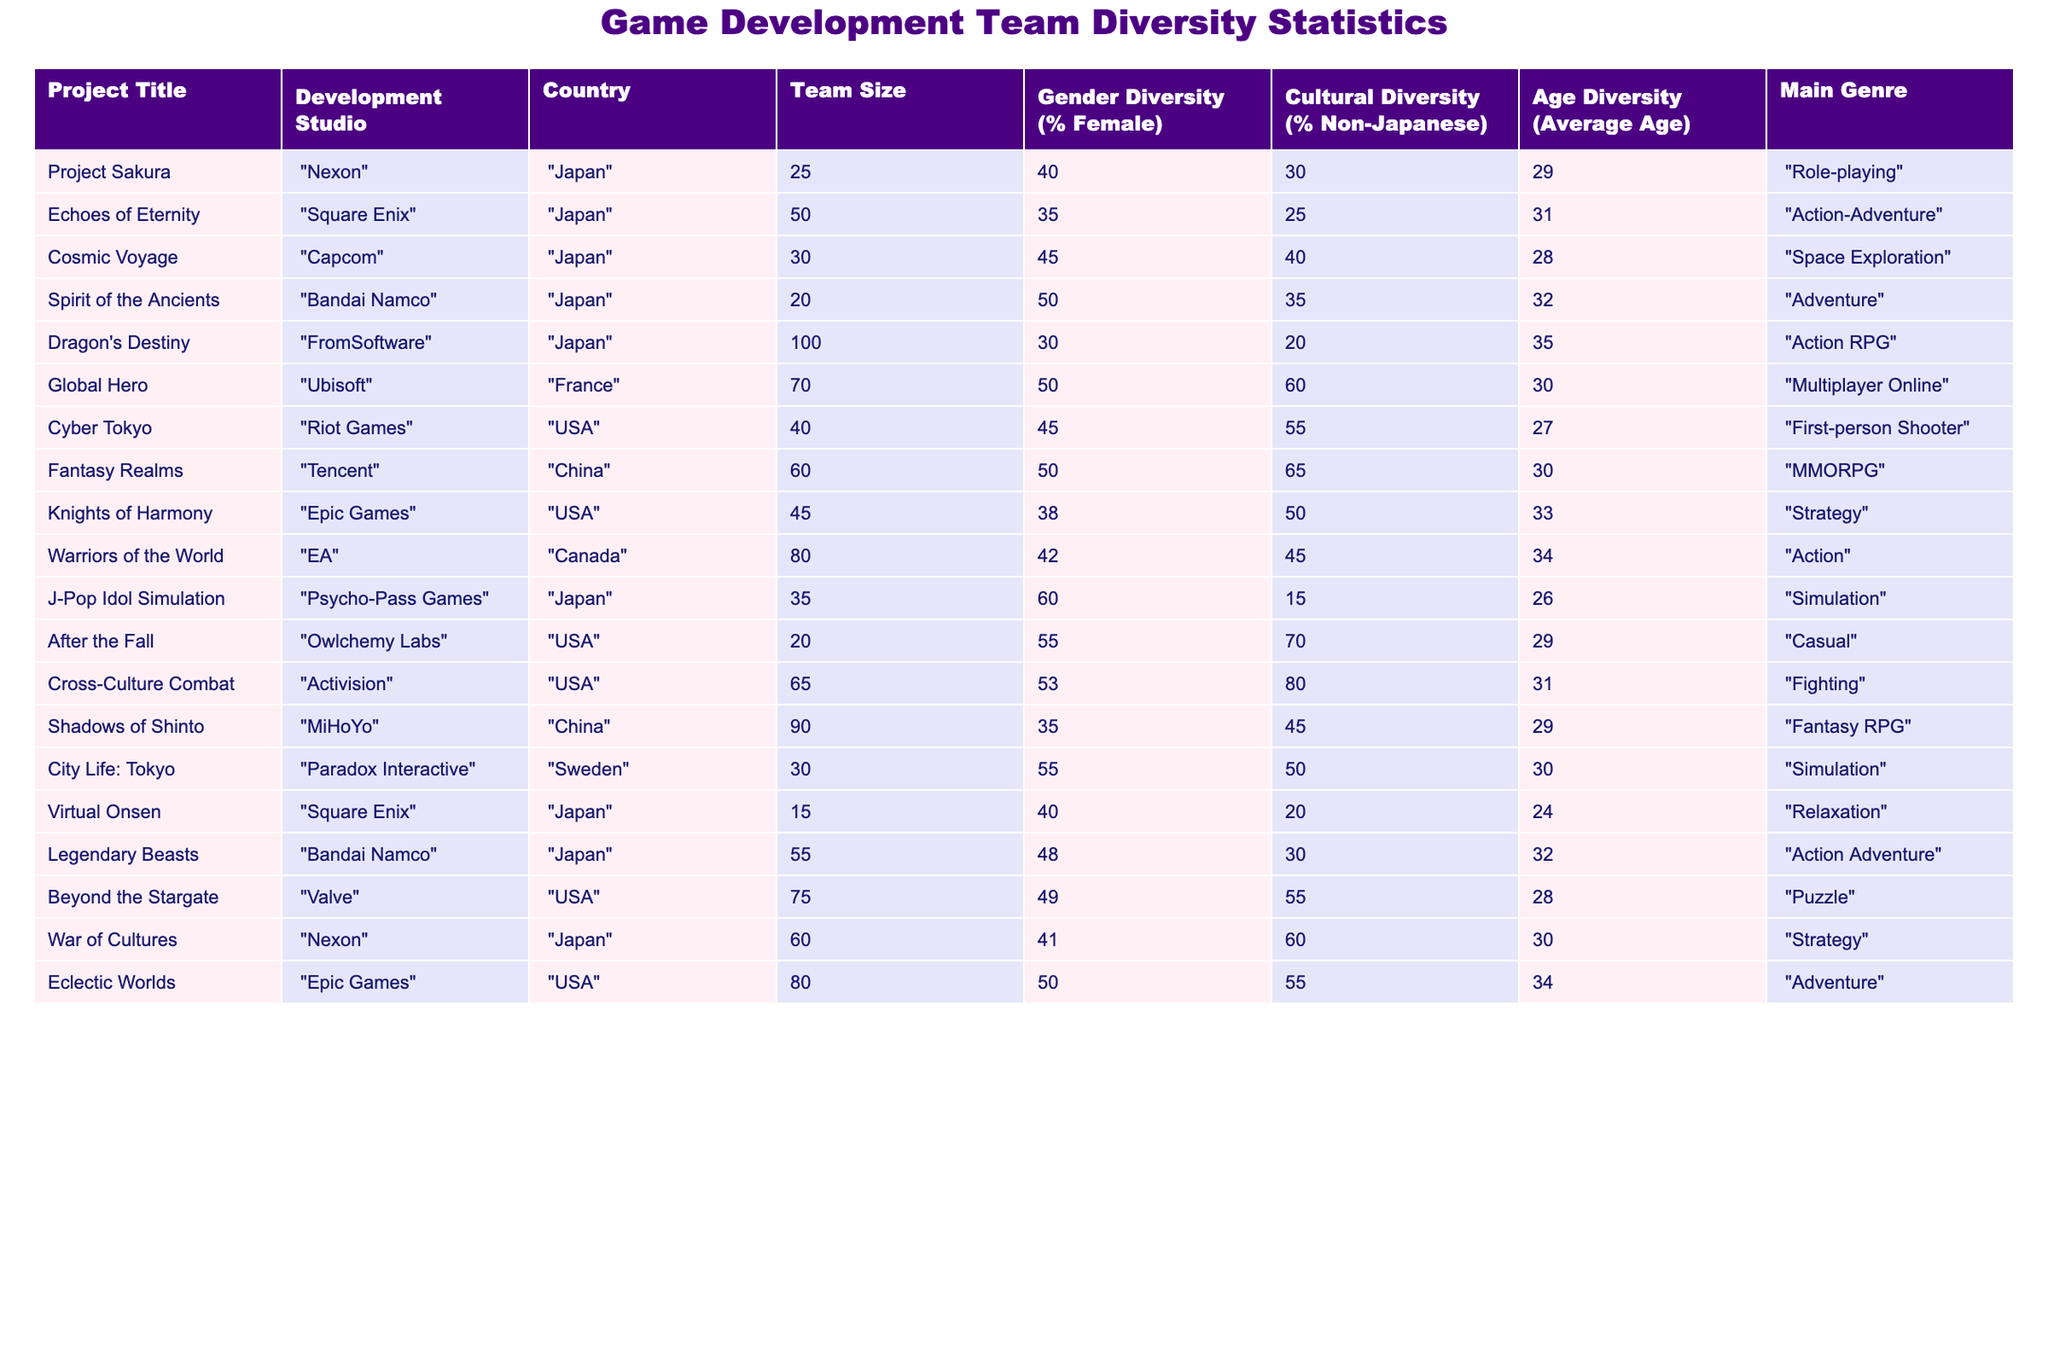What is the project with the highest team size? Comparing the "Team Size" column, the project "Dragon's Destiny" has the largest number of team members at 100.
Answer: Dragon's Destiny Which project has the highest percentage of gender diversity? Looking at the "Gender Diversity (% Female)" column, "J-Pop Idol Simulation" has the highest percentage of female team members at 60%.
Answer: J-Pop Idol Simulation What is the average cultural diversity percentage for projects developed in Japan? We need to look at projects from Japan: "Project Sakura" (30%), "Echoes of Eternity" (25%), "Cosmic Voyage" (40%), "Spirit of the Ancients" (35%), "Dragon's Destiny" (20%), "J-Pop Idol Simulation" (15%), "Virtual Onsen" (20%), "Legendary Beasts" (30%), and "War of Cultures" (60%). Adding these gives a total of 30 + 25 + 40 + 35 + 20 + 15 + 20 + 30 + 60 = 275. There are 9 projects, so the average is 275 / 9 = approximately 30.56%.
Answer: 30.56% Is there a project with both high gender and cultural diversity? Reviewing the data, "Global Hero" has 50% gender diversity and 60% cultural diversity, which are both relatively high compared to other projects.
Answer: Yes, Global Hero Which project has the lowest average age of the team? In the "Age Diversity (Average Age)" column, "Virtual Onsen" has the lowest average age at 24 years.
Answer: Virtual Onsen What is the total team size across all projects listed? To find the total team size, sum the "Team Size" values: 25 + 50 + 30 + 20 + 100 + 70 + 40 + 60 + 45 + 80 + 35 + 20 + 65 + 90 + 30 + 15 + 55 + 75 + 60 + 80 = 1045.
Answer: 1045 Which studio has projects that collectively show more cultural diversity: Japanese or non-Japanese studios? We need to sum the cultural diversity percentages for projects from Japanese studios and compare them to those from non-Japanese studios. For Japan: (30 + 25 + 40 + 35 + 20 + 15 + 20 + 30 + 60) = 275%. For non-Japanese: (50 + 55 + 50 + 42 + 53 + 49 + 50) = 399%. Non-Japanese has a higher total.
Answer: Non-Japanese studios have more cultural diversity How does the average age of the Japanese projects compare with the non-Japanese ones? The average age for Japanese projects is (29 + 31 + 28 + 32 + 35 + 26 + 24 + 32 + 30) = 28.33 years (total 9 values). For non-Japanese: (30 + 27 + 30 + 33 + 34 + 28 + 34) = 30 (total 7 values). This indicates Japanese projects have a younger average age compared to non-Japanese projects.
Answer: Japanese projects are younger Which project has the most varied genre representation? All projects cover diverse genres, but “Cross-Culture Combat” can be noted for its unique genre of fighting games, emphasizing cultural elements. Assessing the table, it also stands out with high cultural diversity percentages.
Answer: Cross-Culture Combat 